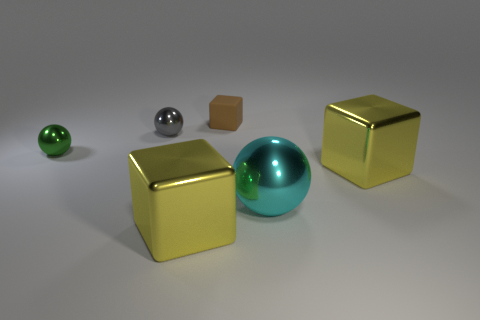Add 1 cylinders. How many objects exist? 7 Subtract all yellow shiny cubes. Subtract all tiny shiny spheres. How many objects are left? 2 Add 1 brown matte blocks. How many brown matte blocks are left? 2 Add 2 large yellow shiny objects. How many large yellow shiny objects exist? 4 Subtract 1 gray spheres. How many objects are left? 5 